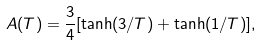<formula> <loc_0><loc_0><loc_500><loc_500>A ( T ) = \frac { 3 } { 4 } [ \tanh ( 3 / T ) + \tanh ( 1 / T ) ] ,</formula> 